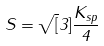Convert formula to latex. <formula><loc_0><loc_0><loc_500><loc_500>S = \sqrt { [ } 3 ] { \frac { K _ { s p } } { 4 } }</formula> 